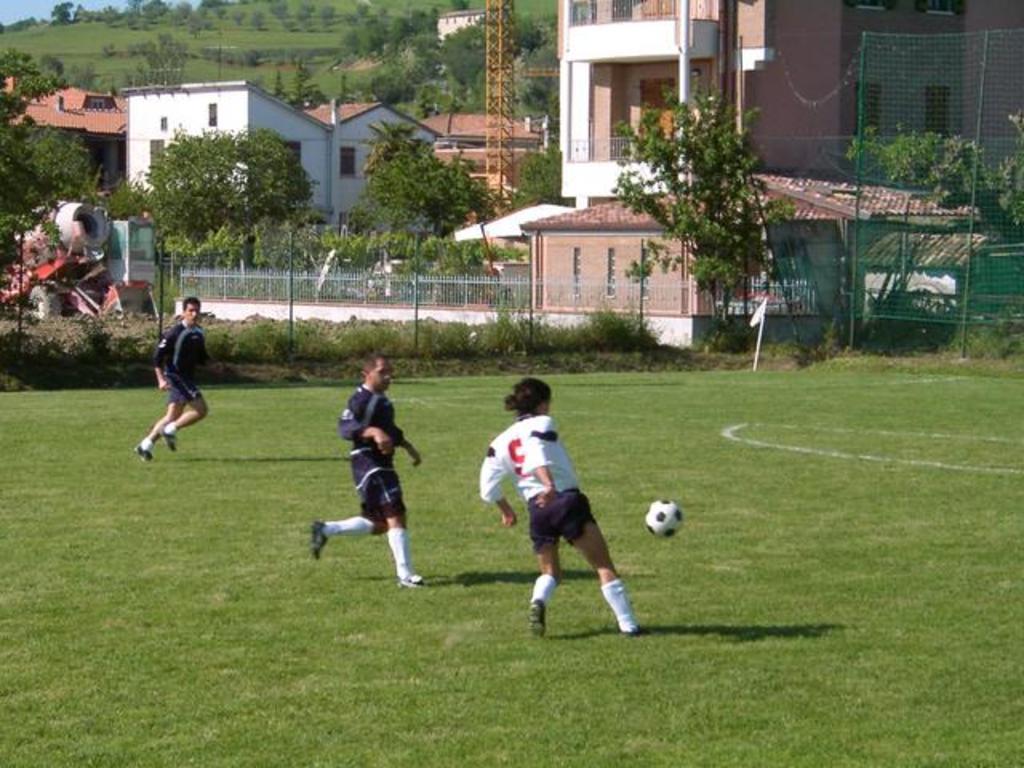Can you describe this image briefly? In this image, I can see three persons playing the football game on the ground. There are buildings, trees, plants, a tower and iron grilles. On the right side of the image, I can see a safety net to the poles. On the left side of the image, there is a vehicle. In the background, I can see a hill and the sky. 